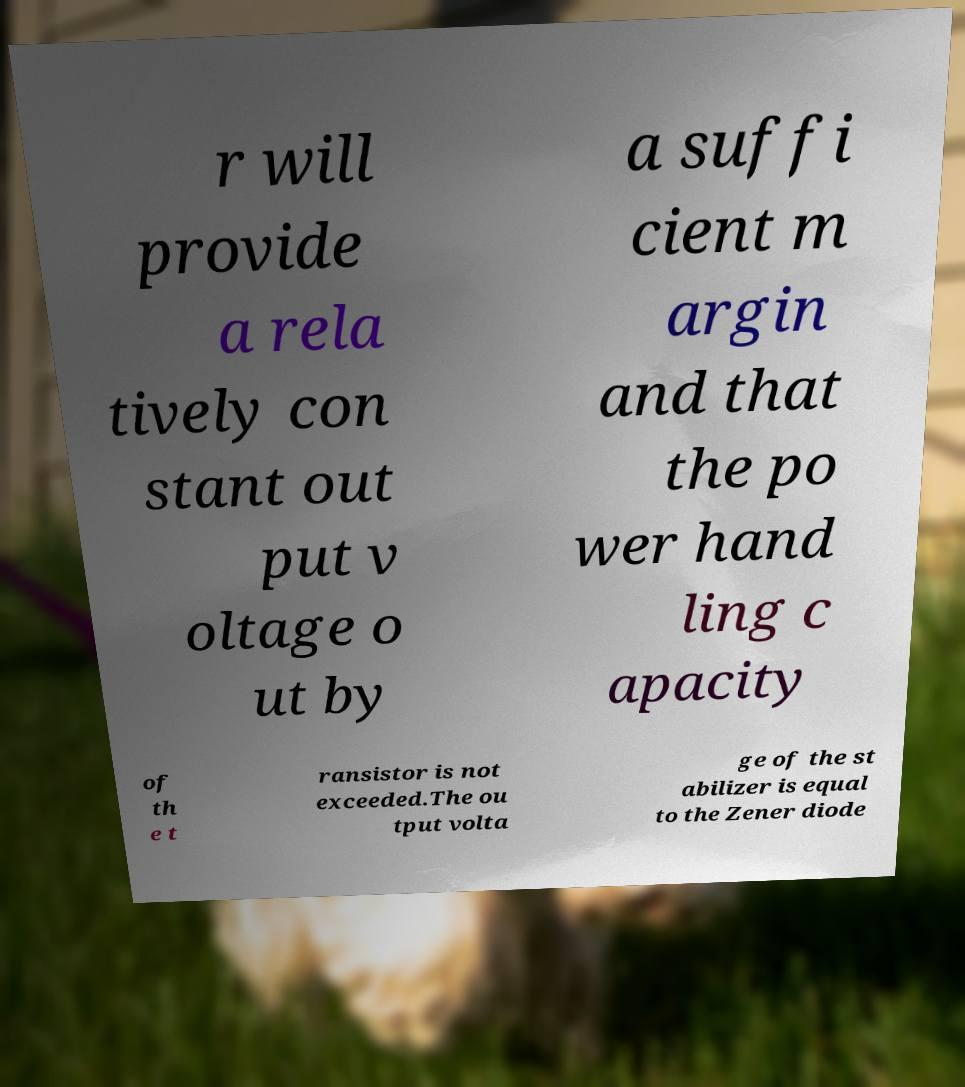I need the written content from this picture converted into text. Can you do that? r will provide a rela tively con stant out put v oltage o ut by a suffi cient m argin and that the po wer hand ling c apacity of th e t ransistor is not exceeded.The ou tput volta ge of the st abilizer is equal to the Zener diode 